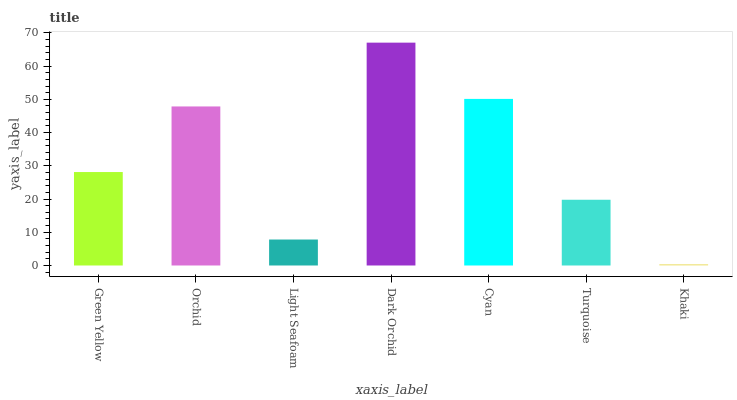Is Khaki the minimum?
Answer yes or no. Yes. Is Dark Orchid the maximum?
Answer yes or no. Yes. Is Orchid the minimum?
Answer yes or no. No. Is Orchid the maximum?
Answer yes or no. No. Is Orchid greater than Green Yellow?
Answer yes or no. Yes. Is Green Yellow less than Orchid?
Answer yes or no. Yes. Is Green Yellow greater than Orchid?
Answer yes or no. No. Is Orchid less than Green Yellow?
Answer yes or no. No. Is Green Yellow the high median?
Answer yes or no. Yes. Is Green Yellow the low median?
Answer yes or no. Yes. Is Orchid the high median?
Answer yes or no. No. Is Khaki the low median?
Answer yes or no. No. 